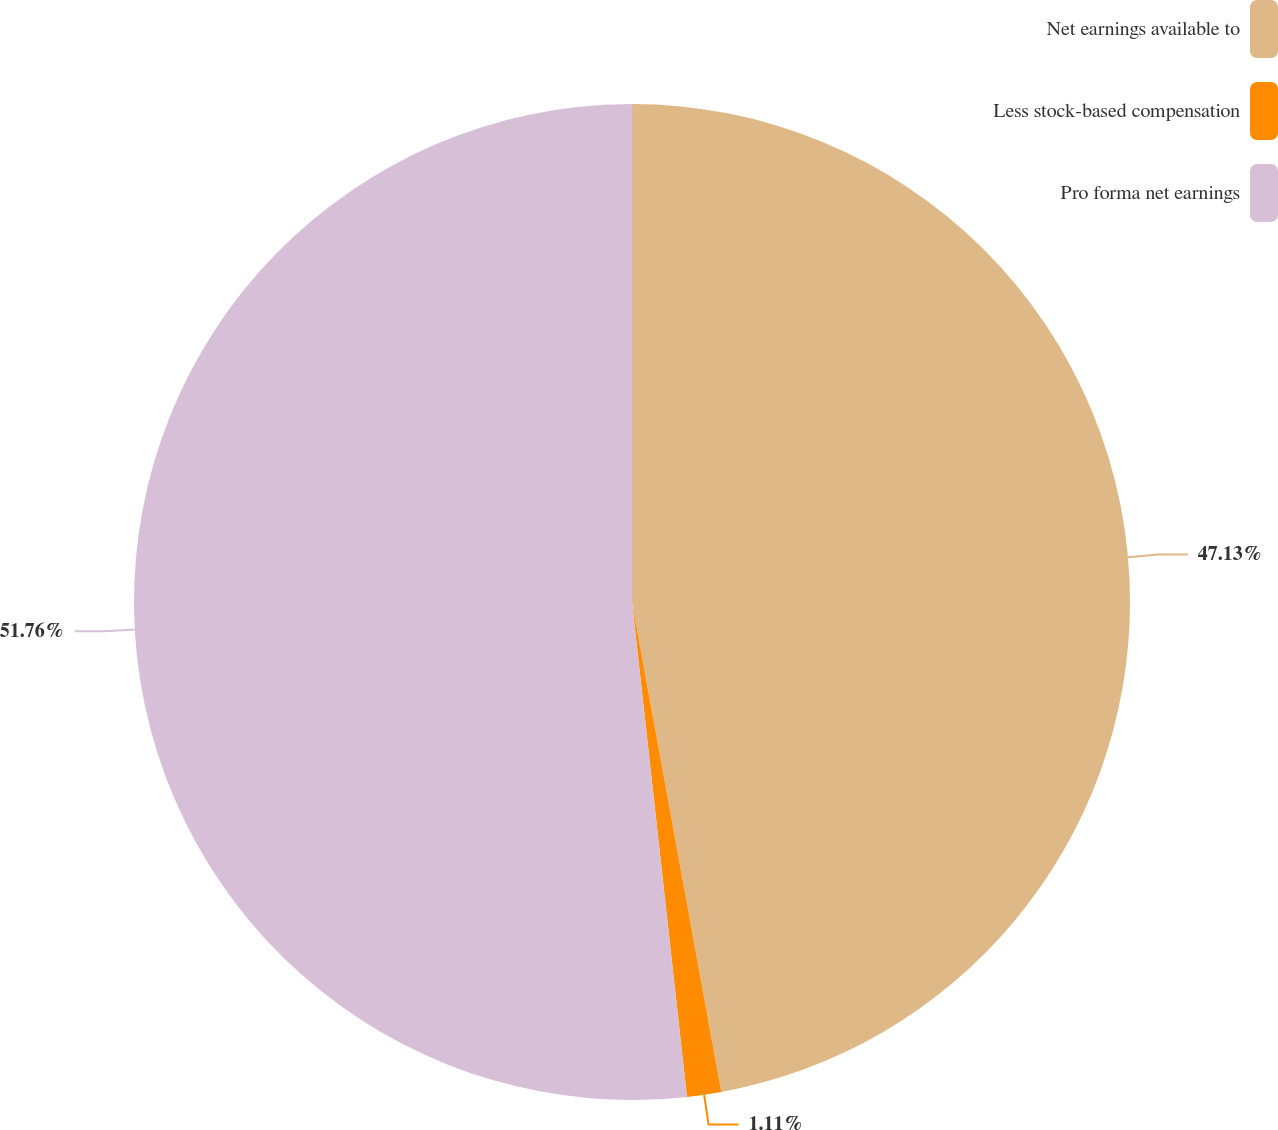<chart> <loc_0><loc_0><loc_500><loc_500><pie_chart><fcel>Net earnings available to<fcel>Less stock-based compensation<fcel>Pro forma net earnings<nl><fcel>47.13%<fcel>1.11%<fcel>51.76%<nl></chart> 